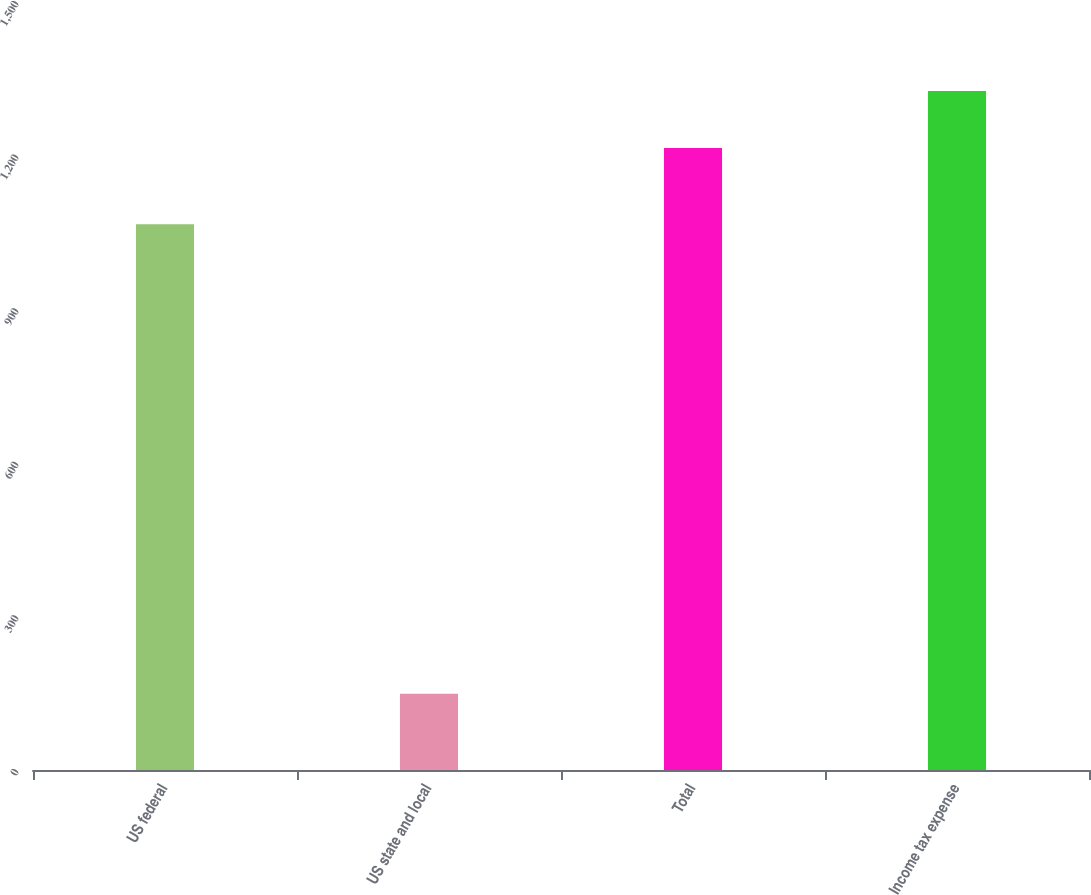Convert chart. <chart><loc_0><loc_0><loc_500><loc_500><bar_chart><fcel>US federal<fcel>US state and local<fcel>Total<fcel>Income tax expense<nl><fcel>1066<fcel>149<fcel>1215<fcel>1326.4<nl></chart> 